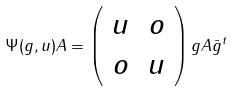Convert formula to latex. <formula><loc_0><loc_0><loc_500><loc_500>\Psi ( g , u ) A = \left ( \begin{array} { c c } u & o \\ o & u \end{array} \right ) g A \bar { g } ^ { t }</formula> 